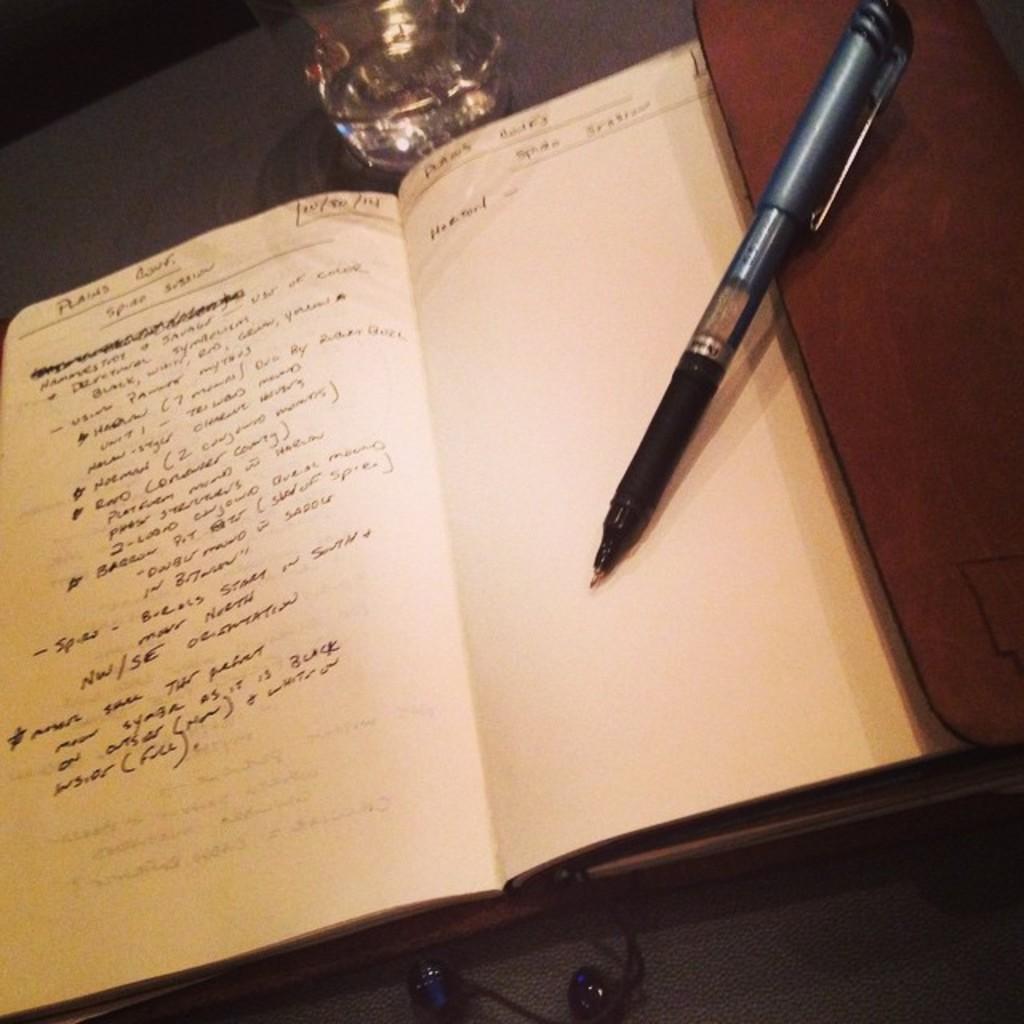How would you summarize this image in a sentence or two? There is a book with white color papers as we can see in the middle of this image. There is a pen on the right side of this image. There is a bottle on the top of this image. 